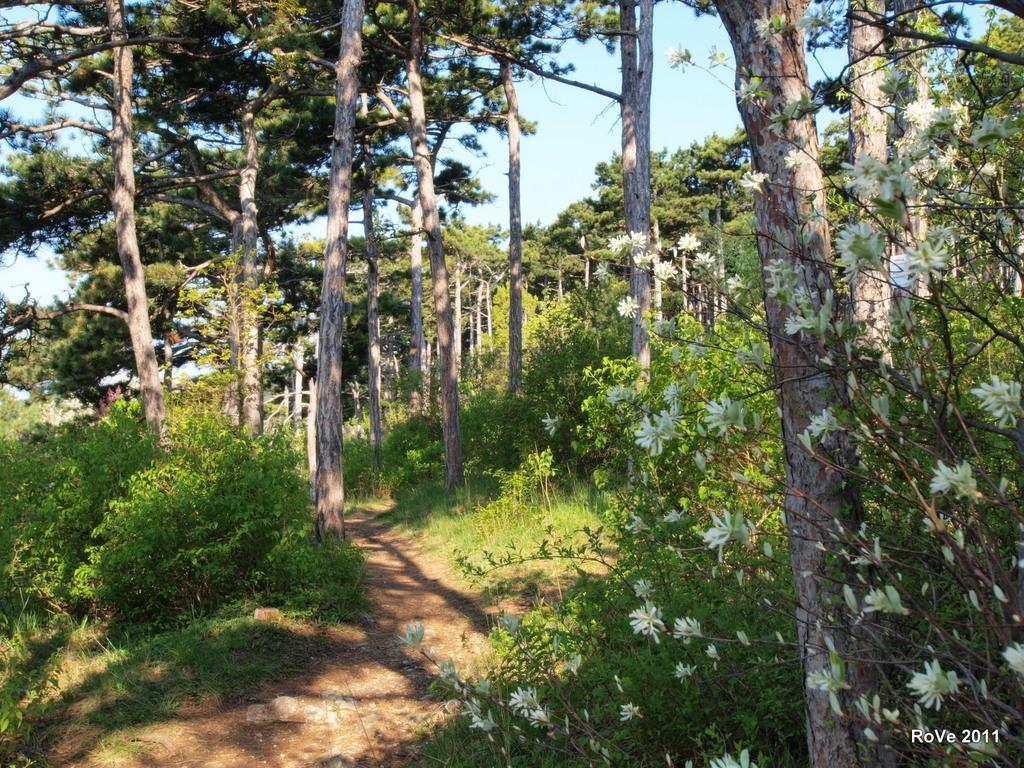Could you give a brief overview of what you see in this image? In the picture we can see a grass surface with plants and flowers to it which are white in color and in the middle we can see a pathway and in the background we can see trees and above it we can see a sky. 